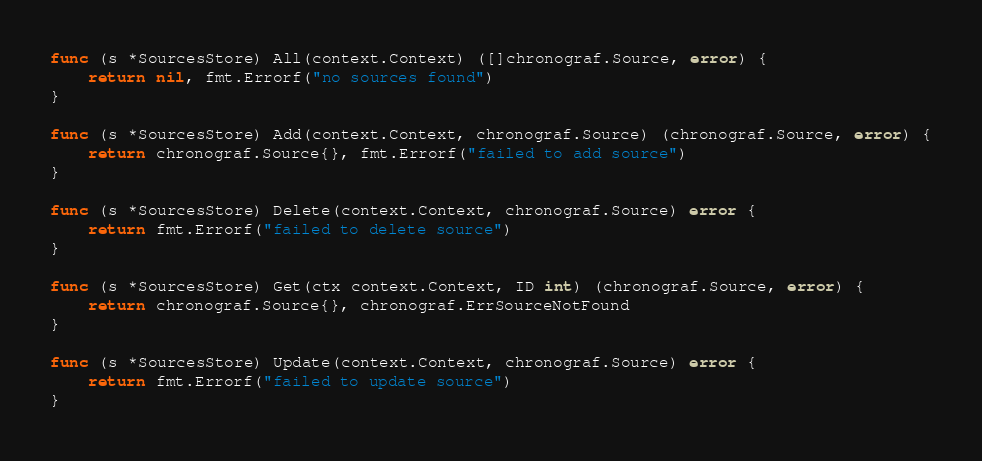<code> <loc_0><loc_0><loc_500><loc_500><_Go_>func (s *SourcesStore) All(context.Context) ([]chronograf.Source, error) {
	return nil, fmt.Errorf("no sources found")
}

func (s *SourcesStore) Add(context.Context, chronograf.Source) (chronograf.Source, error) {
	return chronograf.Source{}, fmt.Errorf("failed to add source")
}

func (s *SourcesStore) Delete(context.Context, chronograf.Source) error {
	return fmt.Errorf("failed to delete source")
}

func (s *SourcesStore) Get(ctx context.Context, ID int) (chronograf.Source, error) {
	return chronograf.Source{}, chronograf.ErrSourceNotFound
}

func (s *SourcesStore) Update(context.Context, chronograf.Source) error {
	return fmt.Errorf("failed to update source")
}
</code> 